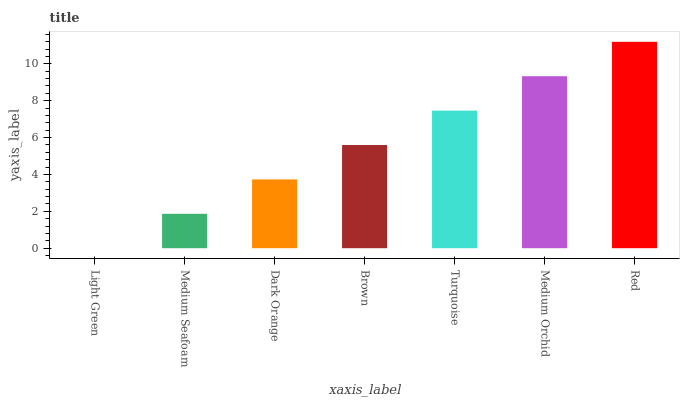Is Light Green the minimum?
Answer yes or no. Yes. Is Red the maximum?
Answer yes or no. Yes. Is Medium Seafoam the minimum?
Answer yes or no. No. Is Medium Seafoam the maximum?
Answer yes or no. No. Is Medium Seafoam greater than Light Green?
Answer yes or no. Yes. Is Light Green less than Medium Seafoam?
Answer yes or no. Yes. Is Light Green greater than Medium Seafoam?
Answer yes or no. No. Is Medium Seafoam less than Light Green?
Answer yes or no. No. Is Brown the high median?
Answer yes or no. Yes. Is Brown the low median?
Answer yes or no. Yes. Is Medium Seafoam the high median?
Answer yes or no. No. Is Medium Seafoam the low median?
Answer yes or no. No. 